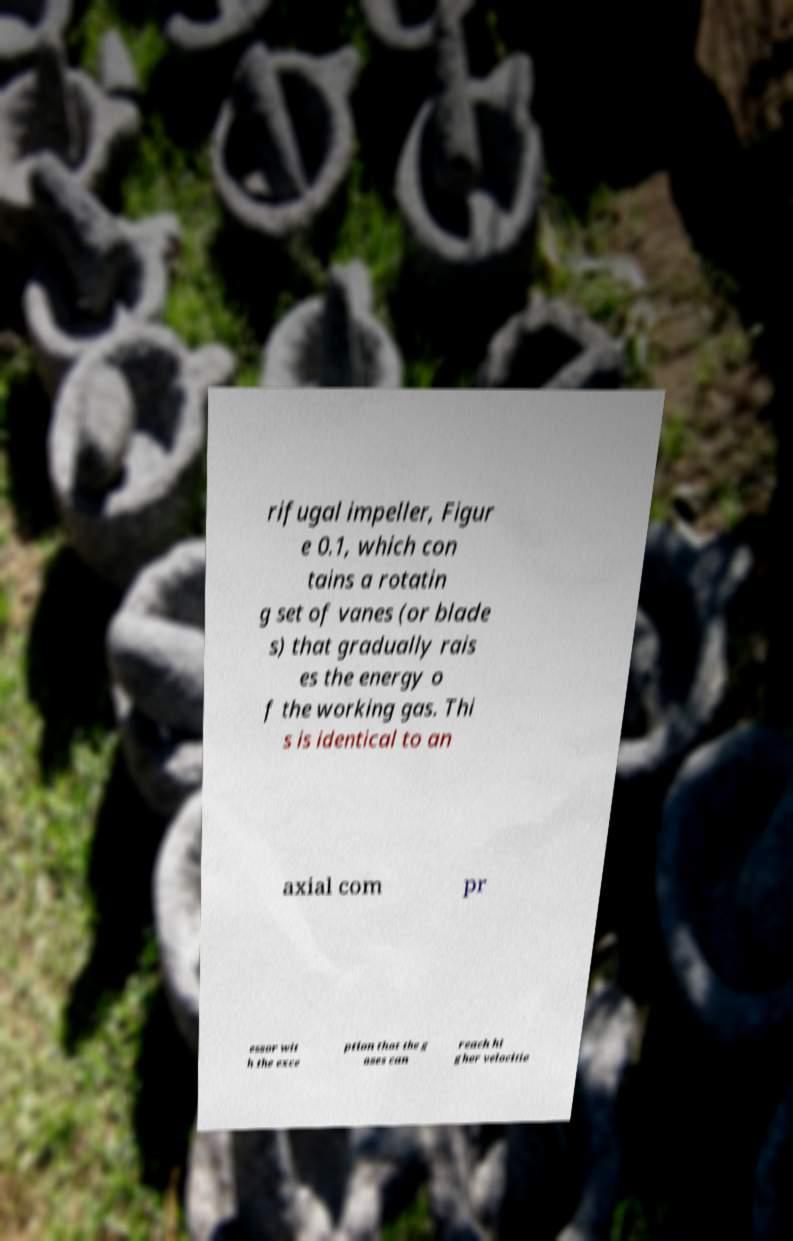Please read and relay the text visible in this image. What does it say? rifugal impeller, Figur e 0.1, which con tains a rotatin g set of vanes (or blade s) that gradually rais es the energy o f the working gas. Thi s is identical to an axial com pr essor wit h the exce ption that the g ases can reach hi gher velocitie 